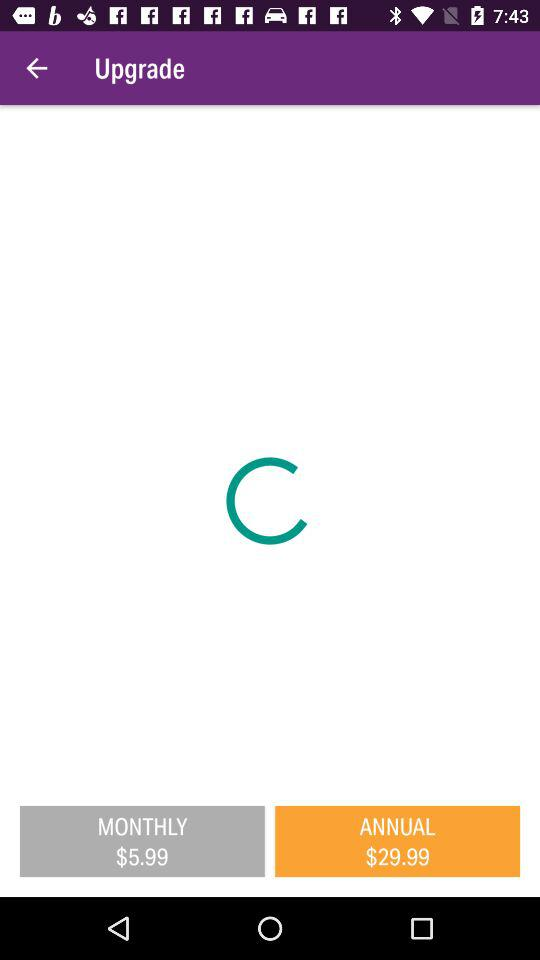What is the monthly price? The monthly price is $5.99. 